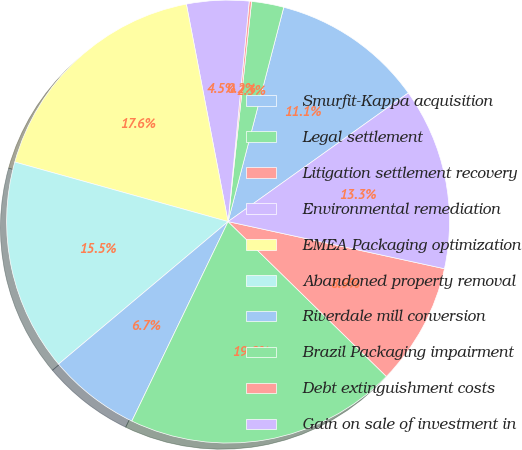Convert chart to OTSL. <chart><loc_0><loc_0><loc_500><loc_500><pie_chart><fcel>Smurfit-Kappa acquisition<fcel>Legal settlement<fcel>Litigation settlement recovery<fcel>Environmental remediation<fcel>EMEA Packaging optimization<fcel>Abandoned property removal<fcel>Riverdale mill conversion<fcel>Brazil Packaging impairment<fcel>Debt extinguishment costs<fcel>Gain on sale of investment in<nl><fcel>11.09%<fcel>2.35%<fcel>0.17%<fcel>4.54%<fcel>17.65%<fcel>15.46%<fcel>6.72%<fcel>19.83%<fcel>8.91%<fcel>13.28%<nl></chart> 